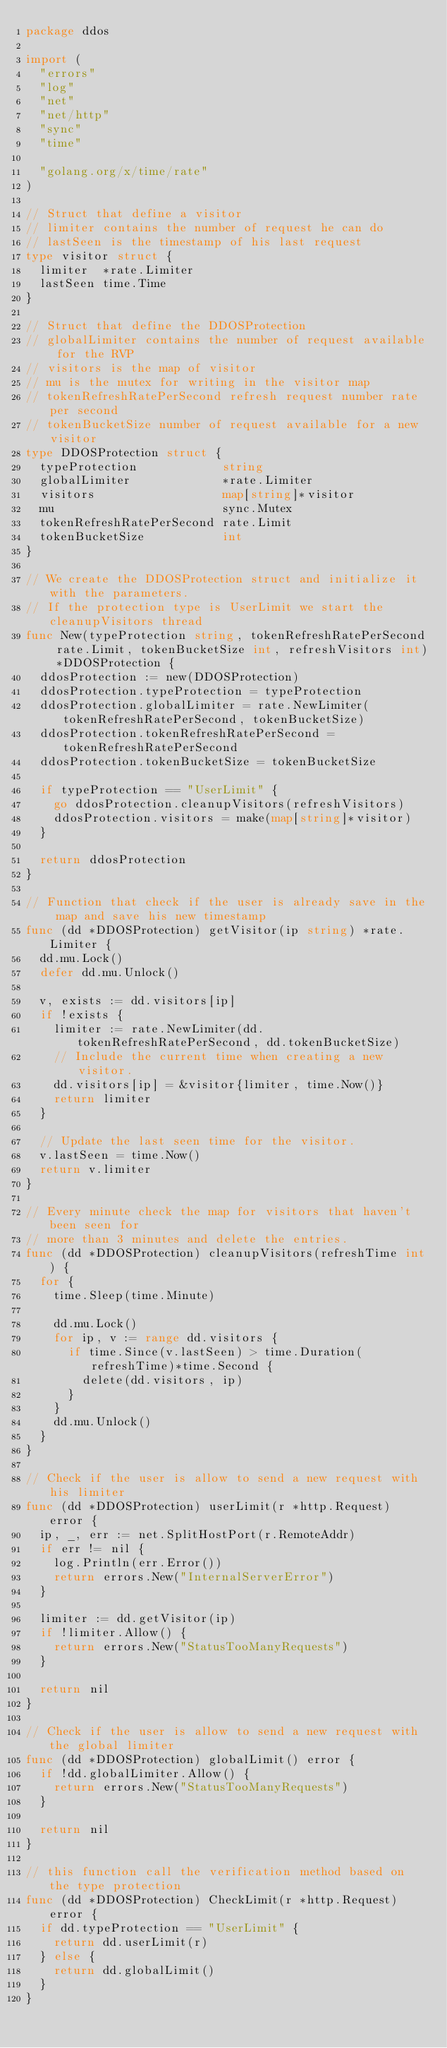Convert code to text. <code><loc_0><loc_0><loc_500><loc_500><_Go_>package ddos

import (
	"errors"
	"log"
	"net"
	"net/http"
	"sync"
	"time"

	"golang.org/x/time/rate"
)

// Struct that define a visitor
// limiter contains the number of request he can do
// lastSeen is the timestamp of his last request
type visitor struct {
	limiter  *rate.Limiter
	lastSeen time.Time
}

// Struct that define the DDOSProtection
// globalLimiter contains the number of request available for the RVP
// visitors is the map of visitor
// mu is the mutex for writing in the visitor map
// tokenRefreshRatePerSecond refresh request number rate per second
// tokenBucketSize number of request available for a new visitor
type DDOSProtection struct {
	typeProtection            string
	globalLimiter             *rate.Limiter
	visitors                  map[string]*visitor
	mu                        sync.Mutex
	tokenRefreshRatePerSecond rate.Limit
	tokenBucketSize           int
}

// We create the DDOSProtection struct and initialize it with the parameters.
// If the protection type is UserLimit we start the cleanupVisitors thread
func New(typeProtection string, tokenRefreshRatePerSecond rate.Limit, tokenBucketSize int, refreshVisitors int) *DDOSProtection {
	ddosProtection := new(DDOSProtection)
	ddosProtection.typeProtection = typeProtection
	ddosProtection.globalLimiter = rate.NewLimiter(tokenRefreshRatePerSecond, tokenBucketSize)
	ddosProtection.tokenRefreshRatePerSecond = tokenRefreshRatePerSecond
	ddosProtection.tokenBucketSize = tokenBucketSize

	if typeProtection == "UserLimit" {
		go ddosProtection.cleanupVisitors(refreshVisitors)
		ddosProtection.visitors = make(map[string]*visitor)
	}

	return ddosProtection
}

// Function that check if the user is already save in the map and save his new timestamp
func (dd *DDOSProtection) getVisitor(ip string) *rate.Limiter {
	dd.mu.Lock()
	defer dd.mu.Unlock()

	v, exists := dd.visitors[ip]
	if !exists {
		limiter := rate.NewLimiter(dd.tokenRefreshRatePerSecond, dd.tokenBucketSize)
		// Include the current time when creating a new visitor.
		dd.visitors[ip] = &visitor{limiter, time.Now()}
		return limiter
	}

	// Update the last seen time for the visitor.
	v.lastSeen = time.Now()
	return v.limiter
}

// Every minute check the map for visitors that haven't been seen for
// more than 3 minutes and delete the entries.
func (dd *DDOSProtection) cleanupVisitors(refreshTime int) {
	for {
		time.Sleep(time.Minute)

		dd.mu.Lock()
		for ip, v := range dd.visitors {
			if time.Since(v.lastSeen) > time.Duration(refreshTime)*time.Second {
				delete(dd.visitors, ip)
			}
		}
		dd.mu.Unlock()
	}
}

// Check if the user is allow to send a new request with his limiter
func (dd *DDOSProtection) userLimit(r *http.Request) error {
	ip, _, err := net.SplitHostPort(r.RemoteAddr)
	if err != nil {
		log.Println(err.Error())
		return errors.New("InternalServerError")
	}

	limiter := dd.getVisitor(ip)
	if !limiter.Allow() {
		return errors.New("StatusTooManyRequests")
	}

	return nil
}

// Check if the user is allow to send a new request with the global limiter
func (dd *DDOSProtection) globalLimit() error {
	if !dd.globalLimiter.Allow() {
		return errors.New("StatusTooManyRequests")
	}

	return nil
}

// this function call the verification method based on the type protection
func (dd *DDOSProtection) CheckLimit(r *http.Request) error {
	if dd.typeProtection == "UserLimit" {
		return dd.userLimit(r)
	} else {
		return dd.globalLimit()
	}
}
</code> 